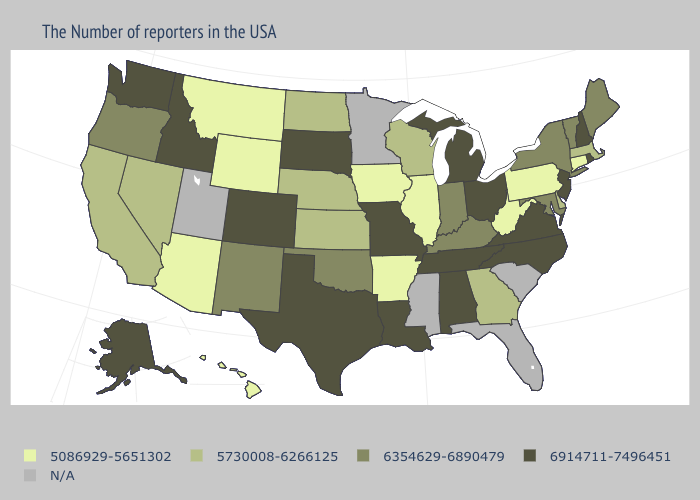What is the lowest value in states that border Colorado?
Write a very short answer. 5086929-5651302. What is the value of Hawaii?
Concise answer only. 5086929-5651302. What is the value of New Jersey?
Keep it brief. 6914711-7496451. Which states have the lowest value in the USA?
Answer briefly. Connecticut, Pennsylvania, West Virginia, Illinois, Arkansas, Iowa, Wyoming, Montana, Arizona, Hawaii. Does Nebraska have the highest value in the MidWest?
Keep it brief. No. Name the states that have a value in the range 5730008-6266125?
Keep it brief. Massachusetts, Delaware, Georgia, Wisconsin, Kansas, Nebraska, North Dakota, Nevada, California. Which states have the lowest value in the USA?
Be succinct. Connecticut, Pennsylvania, West Virginia, Illinois, Arkansas, Iowa, Wyoming, Montana, Arizona, Hawaii. What is the value of New Hampshire?
Keep it brief. 6914711-7496451. Which states have the lowest value in the USA?
Concise answer only. Connecticut, Pennsylvania, West Virginia, Illinois, Arkansas, Iowa, Wyoming, Montana, Arizona, Hawaii. How many symbols are there in the legend?
Concise answer only. 5. Which states have the lowest value in the West?
Quick response, please. Wyoming, Montana, Arizona, Hawaii. What is the lowest value in states that border Wisconsin?
Keep it brief. 5086929-5651302. What is the value of Rhode Island?
Give a very brief answer. 6914711-7496451. 